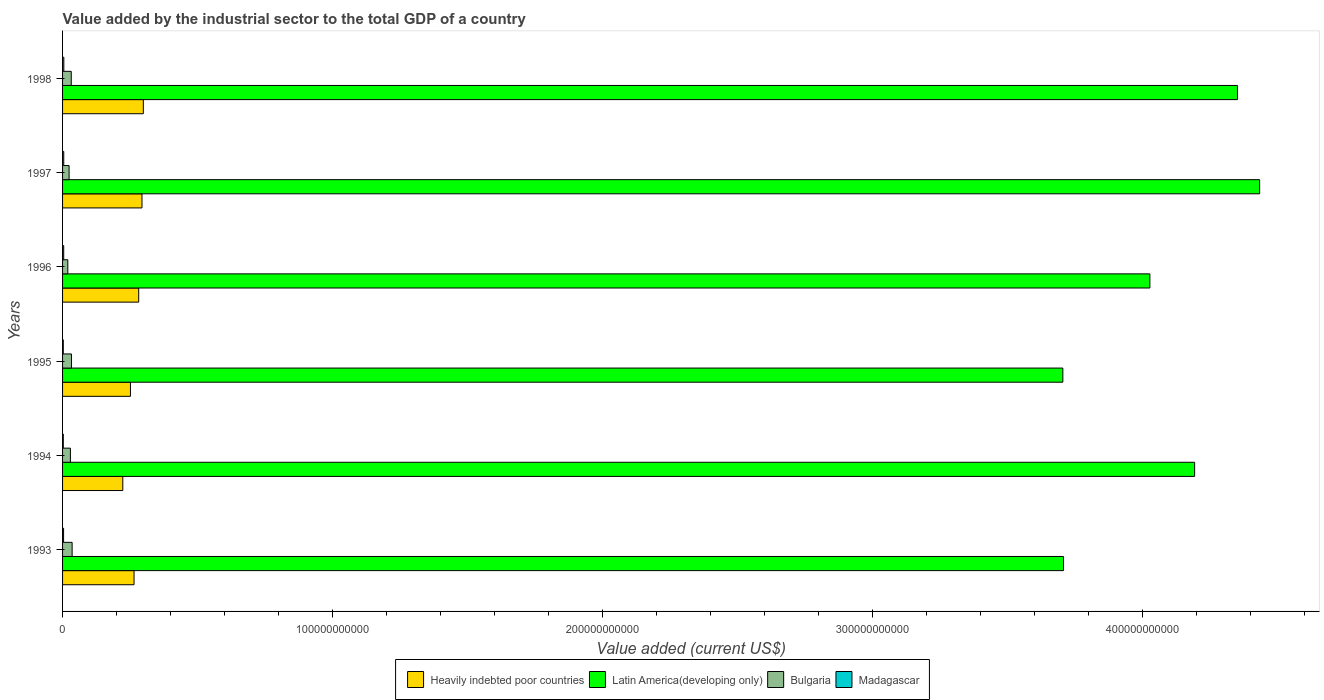How many groups of bars are there?
Your answer should be compact. 6. Are the number of bars per tick equal to the number of legend labels?
Provide a succinct answer. Yes. What is the value added by the industrial sector to the total GDP in Heavily indebted poor countries in 1994?
Ensure brevity in your answer.  2.23e+1. Across all years, what is the maximum value added by the industrial sector to the total GDP in Bulgaria?
Your answer should be compact. 3.54e+09. Across all years, what is the minimum value added by the industrial sector to the total GDP in Heavily indebted poor countries?
Keep it short and to the point. 2.23e+1. In which year was the value added by the industrial sector to the total GDP in Bulgaria maximum?
Give a very brief answer. 1993. What is the total value added by the industrial sector to the total GDP in Bulgaria in the graph?
Keep it short and to the point. 1.73e+1. What is the difference between the value added by the industrial sector to the total GDP in Madagascar in 1994 and that in 1997?
Provide a succinct answer. -1.69e+08. What is the difference between the value added by the industrial sector to the total GDP in Heavily indebted poor countries in 1994 and the value added by the industrial sector to the total GDP in Bulgaria in 1996?
Provide a succinct answer. 2.04e+1. What is the average value added by the industrial sector to the total GDP in Latin America(developing only) per year?
Your answer should be very brief. 4.07e+11. In the year 1993, what is the difference between the value added by the industrial sector to the total GDP in Latin America(developing only) and value added by the industrial sector to the total GDP in Bulgaria?
Provide a succinct answer. 3.67e+11. In how many years, is the value added by the industrial sector to the total GDP in Heavily indebted poor countries greater than 320000000000 US$?
Your response must be concise. 0. What is the ratio of the value added by the industrial sector to the total GDP in Madagascar in 1993 to that in 1996?
Provide a short and direct response. 0.88. Is the value added by the industrial sector to the total GDP in Bulgaria in 1994 less than that in 1998?
Make the answer very short. Yes. What is the difference between the highest and the second highest value added by the industrial sector to the total GDP in Latin America(developing only)?
Make the answer very short. 8.21e+09. What is the difference between the highest and the lowest value added by the industrial sector to the total GDP in Heavily indebted poor countries?
Your response must be concise. 7.60e+09. What does the 4th bar from the top in 1994 represents?
Offer a terse response. Heavily indebted poor countries. What does the 4th bar from the bottom in 1993 represents?
Your answer should be compact. Madagascar. Is it the case that in every year, the sum of the value added by the industrial sector to the total GDP in Heavily indebted poor countries and value added by the industrial sector to the total GDP in Latin America(developing only) is greater than the value added by the industrial sector to the total GDP in Madagascar?
Offer a terse response. Yes. How many bars are there?
Provide a short and direct response. 24. Are all the bars in the graph horizontal?
Your response must be concise. Yes. How many years are there in the graph?
Your response must be concise. 6. What is the difference between two consecutive major ticks on the X-axis?
Keep it short and to the point. 1.00e+11. Does the graph contain grids?
Offer a terse response. No. How are the legend labels stacked?
Your response must be concise. Horizontal. What is the title of the graph?
Provide a short and direct response. Value added by the industrial sector to the total GDP of a country. Does "Hong Kong" appear as one of the legend labels in the graph?
Provide a short and direct response. No. What is the label or title of the X-axis?
Your answer should be very brief. Value added (current US$). What is the Value added (current US$) of Heavily indebted poor countries in 1993?
Keep it short and to the point. 2.65e+1. What is the Value added (current US$) in Latin America(developing only) in 1993?
Offer a terse response. 3.71e+11. What is the Value added (current US$) of Bulgaria in 1993?
Your answer should be very brief. 3.54e+09. What is the Value added (current US$) in Madagascar in 1993?
Your response must be concise. 3.74e+08. What is the Value added (current US$) of Heavily indebted poor countries in 1994?
Provide a short and direct response. 2.23e+1. What is the Value added (current US$) in Latin America(developing only) in 1994?
Give a very brief answer. 4.19e+11. What is the Value added (current US$) of Bulgaria in 1994?
Provide a short and direct response. 2.90e+09. What is the Value added (current US$) of Madagascar in 1994?
Ensure brevity in your answer.  2.72e+08. What is the Value added (current US$) of Heavily indebted poor countries in 1995?
Your response must be concise. 2.51e+1. What is the Value added (current US$) in Latin America(developing only) in 1995?
Your response must be concise. 3.70e+11. What is the Value added (current US$) in Bulgaria in 1995?
Provide a succinct answer. 3.29e+09. What is the Value added (current US$) in Madagascar in 1995?
Provide a short and direct response. 2.71e+08. What is the Value added (current US$) in Heavily indebted poor countries in 1996?
Make the answer very short. 2.82e+1. What is the Value added (current US$) of Latin America(developing only) in 1996?
Your answer should be compact. 4.03e+11. What is the Value added (current US$) of Bulgaria in 1996?
Keep it short and to the point. 1.94e+09. What is the Value added (current US$) of Madagascar in 1996?
Provide a short and direct response. 4.23e+08. What is the Value added (current US$) of Heavily indebted poor countries in 1997?
Make the answer very short. 2.94e+1. What is the Value added (current US$) of Latin America(developing only) in 1997?
Your answer should be compact. 4.43e+11. What is the Value added (current US$) in Bulgaria in 1997?
Your answer should be compact. 2.42e+09. What is the Value added (current US$) in Madagascar in 1997?
Make the answer very short. 4.41e+08. What is the Value added (current US$) in Heavily indebted poor countries in 1998?
Make the answer very short. 2.99e+1. What is the Value added (current US$) of Latin America(developing only) in 1998?
Make the answer very short. 4.35e+11. What is the Value added (current US$) of Bulgaria in 1998?
Provide a short and direct response. 3.21e+09. What is the Value added (current US$) in Madagascar in 1998?
Your response must be concise. 4.69e+08. Across all years, what is the maximum Value added (current US$) of Heavily indebted poor countries?
Make the answer very short. 2.99e+1. Across all years, what is the maximum Value added (current US$) of Latin America(developing only)?
Your answer should be very brief. 4.43e+11. Across all years, what is the maximum Value added (current US$) in Bulgaria?
Offer a terse response. 3.54e+09. Across all years, what is the maximum Value added (current US$) in Madagascar?
Your response must be concise. 4.69e+08. Across all years, what is the minimum Value added (current US$) in Heavily indebted poor countries?
Make the answer very short. 2.23e+1. Across all years, what is the minimum Value added (current US$) of Latin America(developing only)?
Give a very brief answer. 3.70e+11. Across all years, what is the minimum Value added (current US$) in Bulgaria?
Keep it short and to the point. 1.94e+09. Across all years, what is the minimum Value added (current US$) in Madagascar?
Keep it short and to the point. 2.71e+08. What is the total Value added (current US$) in Heavily indebted poor countries in the graph?
Offer a terse response. 1.61e+11. What is the total Value added (current US$) of Latin America(developing only) in the graph?
Provide a succinct answer. 2.44e+12. What is the total Value added (current US$) in Bulgaria in the graph?
Your answer should be very brief. 1.73e+1. What is the total Value added (current US$) in Madagascar in the graph?
Your answer should be compact. 2.25e+09. What is the difference between the Value added (current US$) of Heavily indebted poor countries in 1993 and that in 1994?
Your response must be concise. 4.17e+09. What is the difference between the Value added (current US$) of Latin America(developing only) in 1993 and that in 1994?
Offer a terse response. -4.86e+1. What is the difference between the Value added (current US$) of Bulgaria in 1993 and that in 1994?
Your response must be concise. 6.36e+08. What is the difference between the Value added (current US$) of Madagascar in 1993 and that in 1994?
Make the answer very short. 1.02e+08. What is the difference between the Value added (current US$) of Heavily indebted poor countries in 1993 and that in 1995?
Offer a terse response. 1.33e+09. What is the difference between the Value added (current US$) in Latin America(developing only) in 1993 and that in 1995?
Your answer should be compact. 2.47e+08. What is the difference between the Value added (current US$) in Bulgaria in 1993 and that in 1995?
Provide a succinct answer. 2.48e+08. What is the difference between the Value added (current US$) in Madagascar in 1993 and that in 1995?
Provide a short and direct response. 1.03e+08. What is the difference between the Value added (current US$) of Heavily indebted poor countries in 1993 and that in 1996?
Provide a succinct answer. -1.72e+09. What is the difference between the Value added (current US$) in Latin America(developing only) in 1993 and that in 1996?
Your answer should be very brief. -3.20e+1. What is the difference between the Value added (current US$) of Bulgaria in 1993 and that in 1996?
Give a very brief answer. 1.60e+09. What is the difference between the Value added (current US$) of Madagascar in 1993 and that in 1996?
Ensure brevity in your answer.  -4.89e+07. What is the difference between the Value added (current US$) of Heavily indebted poor countries in 1993 and that in 1997?
Provide a succinct answer. -2.94e+09. What is the difference between the Value added (current US$) in Latin America(developing only) in 1993 and that in 1997?
Offer a terse response. -7.26e+1. What is the difference between the Value added (current US$) in Bulgaria in 1993 and that in 1997?
Give a very brief answer. 1.12e+09. What is the difference between the Value added (current US$) in Madagascar in 1993 and that in 1997?
Offer a very short reply. -6.70e+07. What is the difference between the Value added (current US$) of Heavily indebted poor countries in 1993 and that in 1998?
Your answer should be compact. -3.44e+09. What is the difference between the Value added (current US$) in Latin America(developing only) in 1993 and that in 1998?
Provide a succinct answer. -6.44e+1. What is the difference between the Value added (current US$) of Bulgaria in 1993 and that in 1998?
Your response must be concise. 3.26e+08. What is the difference between the Value added (current US$) of Madagascar in 1993 and that in 1998?
Give a very brief answer. -9.46e+07. What is the difference between the Value added (current US$) of Heavily indebted poor countries in 1994 and that in 1995?
Provide a short and direct response. -2.84e+09. What is the difference between the Value added (current US$) of Latin America(developing only) in 1994 and that in 1995?
Your answer should be very brief. 4.88e+1. What is the difference between the Value added (current US$) of Bulgaria in 1994 and that in 1995?
Ensure brevity in your answer.  -3.88e+08. What is the difference between the Value added (current US$) in Madagascar in 1994 and that in 1995?
Provide a succinct answer. 6.85e+05. What is the difference between the Value added (current US$) of Heavily indebted poor countries in 1994 and that in 1996?
Give a very brief answer. -5.89e+09. What is the difference between the Value added (current US$) of Latin America(developing only) in 1994 and that in 1996?
Your answer should be compact. 1.66e+1. What is the difference between the Value added (current US$) in Bulgaria in 1994 and that in 1996?
Make the answer very short. 9.64e+08. What is the difference between the Value added (current US$) of Madagascar in 1994 and that in 1996?
Give a very brief answer. -1.51e+08. What is the difference between the Value added (current US$) in Heavily indebted poor countries in 1994 and that in 1997?
Provide a short and direct response. -7.11e+09. What is the difference between the Value added (current US$) of Latin America(developing only) in 1994 and that in 1997?
Your answer should be compact. -2.41e+1. What is the difference between the Value added (current US$) in Bulgaria in 1994 and that in 1997?
Offer a terse response. 4.88e+08. What is the difference between the Value added (current US$) of Madagascar in 1994 and that in 1997?
Offer a very short reply. -1.69e+08. What is the difference between the Value added (current US$) in Heavily indebted poor countries in 1994 and that in 1998?
Give a very brief answer. -7.60e+09. What is the difference between the Value added (current US$) in Latin America(developing only) in 1994 and that in 1998?
Give a very brief answer. -1.59e+1. What is the difference between the Value added (current US$) in Bulgaria in 1994 and that in 1998?
Your response must be concise. -3.10e+08. What is the difference between the Value added (current US$) of Madagascar in 1994 and that in 1998?
Give a very brief answer. -1.97e+08. What is the difference between the Value added (current US$) of Heavily indebted poor countries in 1995 and that in 1996?
Provide a succinct answer. -3.05e+09. What is the difference between the Value added (current US$) of Latin America(developing only) in 1995 and that in 1996?
Offer a very short reply. -3.22e+1. What is the difference between the Value added (current US$) in Bulgaria in 1995 and that in 1996?
Keep it short and to the point. 1.35e+09. What is the difference between the Value added (current US$) of Madagascar in 1995 and that in 1996?
Keep it short and to the point. -1.52e+08. What is the difference between the Value added (current US$) in Heavily indebted poor countries in 1995 and that in 1997?
Give a very brief answer. -4.27e+09. What is the difference between the Value added (current US$) in Latin America(developing only) in 1995 and that in 1997?
Keep it short and to the point. -7.29e+1. What is the difference between the Value added (current US$) of Bulgaria in 1995 and that in 1997?
Keep it short and to the point. 8.76e+08. What is the difference between the Value added (current US$) of Madagascar in 1995 and that in 1997?
Your response must be concise. -1.70e+08. What is the difference between the Value added (current US$) in Heavily indebted poor countries in 1995 and that in 1998?
Offer a very short reply. -4.77e+09. What is the difference between the Value added (current US$) in Latin America(developing only) in 1995 and that in 1998?
Provide a succinct answer. -6.47e+1. What is the difference between the Value added (current US$) of Bulgaria in 1995 and that in 1998?
Offer a terse response. 7.84e+07. What is the difference between the Value added (current US$) in Madagascar in 1995 and that in 1998?
Make the answer very short. -1.98e+08. What is the difference between the Value added (current US$) in Heavily indebted poor countries in 1996 and that in 1997?
Ensure brevity in your answer.  -1.22e+09. What is the difference between the Value added (current US$) in Latin America(developing only) in 1996 and that in 1997?
Your answer should be very brief. -4.07e+1. What is the difference between the Value added (current US$) in Bulgaria in 1996 and that in 1997?
Provide a succinct answer. -4.76e+08. What is the difference between the Value added (current US$) in Madagascar in 1996 and that in 1997?
Provide a succinct answer. -1.81e+07. What is the difference between the Value added (current US$) of Heavily indebted poor countries in 1996 and that in 1998?
Offer a very short reply. -1.72e+09. What is the difference between the Value added (current US$) in Latin America(developing only) in 1996 and that in 1998?
Give a very brief answer. -3.24e+1. What is the difference between the Value added (current US$) of Bulgaria in 1996 and that in 1998?
Your answer should be very brief. -1.27e+09. What is the difference between the Value added (current US$) in Madagascar in 1996 and that in 1998?
Make the answer very short. -4.58e+07. What is the difference between the Value added (current US$) in Heavily indebted poor countries in 1997 and that in 1998?
Give a very brief answer. -4.99e+08. What is the difference between the Value added (current US$) in Latin America(developing only) in 1997 and that in 1998?
Provide a short and direct response. 8.21e+09. What is the difference between the Value added (current US$) in Bulgaria in 1997 and that in 1998?
Make the answer very short. -7.97e+08. What is the difference between the Value added (current US$) in Madagascar in 1997 and that in 1998?
Offer a terse response. -2.76e+07. What is the difference between the Value added (current US$) in Heavily indebted poor countries in 1993 and the Value added (current US$) in Latin America(developing only) in 1994?
Provide a succinct answer. -3.93e+11. What is the difference between the Value added (current US$) in Heavily indebted poor countries in 1993 and the Value added (current US$) in Bulgaria in 1994?
Provide a succinct answer. 2.36e+1. What is the difference between the Value added (current US$) of Heavily indebted poor countries in 1993 and the Value added (current US$) of Madagascar in 1994?
Keep it short and to the point. 2.62e+1. What is the difference between the Value added (current US$) in Latin America(developing only) in 1993 and the Value added (current US$) in Bulgaria in 1994?
Offer a very short reply. 3.68e+11. What is the difference between the Value added (current US$) of Latin America(developing only) in 1993 and the Value added (current US$) of Madagascar in 1994?
Ensure brevity in your answer.  3.70e+11. What is the difference between the Value added (current US$) in Bulgaria in 1993 and the Value added (current US$) in Madagascar in 1994?
Give a very brief answer. 3.27e+09. What is the difference between the Value added (current US$) of Heavily indebted poor countries in 1993 and the Value added (current US$) of Latin America(developing only) in 1995?
Keep it short and to the point. -3.44e+11. What is the difference between the Value added (current US$) of Heavily indebted poor countries in 1993 and the Value added (current US$) of Bulgaria in 1995?
Your response must be concise. 2.32e+1. What is the difference between the Value added (current US$) of Heavily indebted poor countries in 1993 and the Value added (current US$) of Madagascar in 1995?
Provide a short and direct response. 2.62e+1. What is the difference between the Value added (current US$) in Latin America(developing only) in 1993 and the Value added (current US$) in Bulgaria in 1995?
Your response must be concise. 3.67e+11. What is the difference between the Value added (current US$) of Latin America(developing only) in 1993 and the Value added (current US$) of Madagascar in 1995?
Offer a terse response. 3.70e+11. What is the difference between the Value added (current US$) in Bulgaria in 1993 and the Value added (current US$) in Madagascar in 1995?
Your answer should be very brief. 3.27e+09. What is the difference between the Value added (current US$) in Heavily indebted poor countries in 1993 and the Value added (current US$) in Latin America(developing only) in 1996?
Offer a terse response. -3.76e+11. What is the difference between the Value added (current US$) in Heavily indebted poor countries in 1993 and the Value added (current US$) in Bulgaria in 1996?
Your answer should be compact. 2.45e+1. What is the difference between the Value added (current US$) of Heavily indebted poor countries in 1993 and the Value added (current US$) of Madagascar in 1996?
Your answer should be very brief. 2.60e+1. What is the difference between the Value added (current US$) in Latin America(developing only) in 1993 and the Value added (current US$) in Bulgaria in 1996?
Your response must be concise. 3.69e+11. What is the difference between the Value added (current US$) in Latin America(developing only) in 1993 and the Value added (current US$) in Madagascar in 1996?
Keep it short and to the point. 3.70e+11. What is the difference between the Value added (current US$) of Bulgaria in 1993 and the Value added (current US$) of Madagascar in 1996?
Your answer should be very brief. 3.12e+09. What is the difference between the Value added (current US$) in Heavily indebted poor countries in 1993 and the Value added (current US$) in Latin America(developing only) in 1997?
Your response must be concise. -4.17e+11. What is the difference between the Value added (current US$) in Heavily indebted poor countries in 1993 and the Value added (current US$) in Bulgaria in 1997?
Make the answer very short. 2.41e+1. What is the difference between the Value added (current US$) in Heavily indebted poor countries in 1993 and the Value added (current US$) in Madagascar in 1997?
Make the answer very short. 2.60e+1. What is the difference between the Value added (current US$) of Latin America(developing only) in 1993 and the Value added (current US$) of Bulgaria in 1997?
Give a very brief answer. 3.68e+11. What is the difference between the Value added (current US$) of Latin America(developing only) in 1993 and the Value added (current US$) of Madagascar in 1997?
Your answer should be very brief. 3.70e+11. What is the difference between the Value added (current US$) in Bulgaria in 1993 and the Value added (current US$) in Madagascar in 1997?
Keep it short and to the point. 3.10e+09. What is the difference between the Value added (current US$) in Heavily indebted poor countries in 1993 and the Value added (current US$) in Latin America(developing only) in 1998?
Your response must be concise. -4.09e+11. What is the difference between the Value added (current US$) in Heavily indebted poor countries in 1993 and the Value added (current US$) in Bulgaria in 1998?
Your response must be concise. 2.33e+1. What is the difference between the Value added (current US$) in Heavily indebted poor countries in 1993 and the Value added (current US$) in Madagascar in 1998?
Your answer should be compact. 2.60e+1. What is the difference between the Value added (current US$) of Latin America(developing only) in 1993 and the Value added (current US$) of Bulgaria in 1998?
Make the answer very short. 3.67e+11. What is the difference between the Value added (current US$) of Latin America(developing only) in 1993 and the Value added (current US$) of Madagascar in 1998?
Offer a very short reply. 3.70e+11. What is the difference between the Value added (current US$) of Bulgaria in 1993 and the Value added (current US$) of Madagascar in 1998?
Make the answer very short. 3.07e+09. What is the difference between the Value added (current US$) of Heavily indebted poor countries in 1994 and the Value added (current US$) of Latin America(developing only) in 1995?
Your answer should be very brief. -3.48e+11. What is the difference between the Value added (current US$) of Heavily indebted poor countries in 1994 and the Value added (current US$) of Bulgaria in 1995?
Offer a terse response. 1.90e+1. What is the difference between the Value added (current US$) of Heavily indebted poor countries in 1994 and the Value added (current US$) of Madagascar in 1995?
Your answer should be compact. 2.20e+1. What is the difference between the Value added (current US$) in Latin America(developing only) in 1994 and the Value added (current US$) in Bulgaria in 1995?
Provide a short and direct response. 4.16e+11. What is the difference between the Value added (current US$) in Latin America(developing only) in 1994 and the Value added (current US$) in Madagascar in 1995?
Give a very brief answer. 4.19e+11. What is the difference between the Value added (current US$) of Bulgaria in 1994 and the Value added (current US$) of Madagascar in 1995?
Provide a short and direct response. 2.63e+09. What is the difference between the Value added (current US$) of Heavily indebted poor countries in 1994 and the Value added (current US$) of Latin America(developing only) in 1996?
Provide a succinct answer. -3.80e+11. What is the difference between the Value added (current US$) in Heavily indebted poor countries in 1994 and the Value added (current US$) in Bulgaria in 1996?
Make the answer very short. 2.04e+1. What is the difference between the Value added (current US$) in Heavily indebted poor countries in 1994 and the Value added (current US$) in Madagascar in 1996?
Provide a succinct answer. 2.19e+1. What is the difference between the Value added (current US$) in Latin America(developing only) in 1994 and the Value added (current US$) in Bulgaria in 1996?
Provide a succinct answer. 4.17e+11. What is the difference between the Value added (current US$) of Latin America(developing only) in 1994 and the Value added (current US$) of Madagascar in 1996?
Your answer should be very brief. 4.19e+11. What is the difference between the Value added (current US$) in Bulgaria in 1994 and the Value added (current US$) in Madagascar in 1996?
Provide a succinct answer. 2.48e+09. What is the difference between the Value added (current US$) in Heavily indebted poor countries in 1994 and the Value added (current US$) in Latin America(developing only) in 1997?
Your answer should be compact. -4.21e+11. What is the difference between the Value added (current US$) in Heavily indebted poor countries in 1994 and the Value added (current US$) in Bulgaria in 1997?
Give a very brief answer. 1.99e+1. What is the difference between the Value added (current US$) of Heavily indebted poor countries in 1994 and the Value added (current US$) of Madagascar in 1997?
Provide a short and direct response. 2.19e+1. What is the difference between the Value added (current US$) of Latin America(developing only) in 1994 and the Value added (current US$) of Bulgaria in 1997?
Make the answer very short. 4.17e+11. What is the difference between the Value added (current US$) of Latin America(developing only) in 1994 and the Value added (current US$) of Madagascar in 1997?
Give a very brief answer. 4.19e+11. What is the difference between the Value added (current US$) of Bulgaria in 1994 and the Value added (current US$) of Madagascar in 1997?
Offer a terse response. 2.46e+09. What is the difference between the Value added (current US$) of Heavily indebted poor countries in 1994 and the Value added (current US$) of Latin America(developing only) in 1998?
Offer a very short reply. -4.13e+11. What is the difference between the Value added (current US$) of Heavily indebted poor countries in 1994 and the Value added (current US$) of Bulgaria in 1998?
Offer a terse response. 1.91e+1. What is the difference between the Value added (current US$) of Heavily indebted poor countries in 1994 and the Value added (current US$) of Madagascar in 1998?
Offer a terse response. 2.18e+1. What is the difference between the Value added (current US$) in Latin America(developing only) in 1994 and the Value added (current US$) in Bulgaria in 1998?
Your response must be concise. 4.16e+11. What is the difference between the Value added (current US$) in Latin America(developing only) in 1994 and the Value added (current US$) in Madagascar in 1998?
Give a very brief answer. 4.19e+11. What is the difference between the Value added (current US$) of Bulgaria in 1994 and the Value added (current US$) of Madagascar in 1998?
Make the answer very short. 2.44e+09. What is the difference between the Value added (current US$) in Heavily indebted poor countries in 1995 and the Value added (current US$) in Latin America(developing only) in 1996?
Provide a succinct answer. -3.78e+11. What is the difference between the Value added (current US$) of Heavily indebted poor countries in 1995 and the Value added (current US$) of Bulgaria in 1996?
Keep it short and to the point. 2.32e+1. What is the difference between the Value added (current US$) of Heavily indebted poor countries in 1995 and the Value added (current US$) of Madagascar in 1996?
Your response must be concise. 2.47e+1. What is the difference between the Value added (current US$) in Latin America(developing only) in 1995 and the Value added (current US$) in Bulgaria in 1996?
Ensure brevity in your answer.  3.68e+11. What is the difference between the Value added (current US$) in Latin America(developing only) in 1995 and the Value added (current US$) in Madagascar in 1996?
Make the answer very short. 3.70e+11. What is the difference between the Value added (current US$) of Bulgaria in 1995 and the Value added (current US$) of Madagascar in 1996?
Provide a succinct answer. 2.87e+09. What is the difference between the Value added (current US$) of Heavily indebted poor countries in 1995 and the Value added (current US$) of Latin America(developing only) in 1997?
Offer a very short reply. -4.18e+11. What is the difference between the Value added (current US$) in Heavily indebted poor countries in 1995 and the Value added (current US$) in Bulgaria in 1997?
Make the answer very short. 2.27e+1. What is the difference between the Value added (current US$) of Heavily indebted poor countries in 1995 and the Value added (current US$) of Madagascar in 1997?
Provide a short and direct response. 2.47e+1. What is the difference between the Value added (current US$) in Latin America(developing only) in 1995 and the Value added (current US$) in Bulgaria in 1997?
Your answer should be very brief. 3.68e+11. What is the difference between the Value added (current US$) of Latin America(developing only) in 1995 and the Value added (current US$) of Madagascar in 1997?
Offer a terse response. 3.70e+11. What is the difference between the Value added (current US$) of Bulgaria in 1995 and the Value added (current US$) of Madagascar in 1997?
Your answer should be compact. 2.85e+09. What is the difference between the Value added (current US$) of Heavily indebted poor countries in 1995 and the Value added (current US$) of Latin America(developing only) in 1998?
Your response must be concise. -4.10e+11. What is the difference between the Value added (current US$) of Heavily indebted poor countries in 1995 and the Value added (current US$) of Bulgaria in 1998?
Keep it short and to the point. 2.19e+1. What is the difference between the Value added (current US$) in Heavily indebted poor countries in 1995 and the Value added (current US$) in Madagascar in 1998?
Keep it short and to the point. 2.47e+1. What is the difference between the Value added (current US$) in Latin America(developing only) in 1995 and the Value added (current US$) in Bulgaria in 1998?
Keep it short and to the point. 3.67e+11. What is the difference between the Value added (current US$) in Latin America(developing only) in 1995 and the Value added (current US$) in Madagascar in 1998?
Provide a short and direct response. 3.70e+11. What is the difference between the Value added (current US$) of Bulgaria in 1995 and the Value added (current US$) of Madagascar in 1998?
Provide a short and direct response. 2.82e+09. What is the difference between the Value added (current US$) in Heavily indebted poor countries in 1996 and the Value added (current US$) in Latin America(developing only) in 1997?
Ensure brevity in your answer.  -4.15e+11. What is the difference between the Value added (current US$) in Heavily indebted poor countries in 1996 and the Value added (current US$) in Bulgaria in 1997?
Provide a succinct answer. 2.58e+1. What is the difference between the Value added (current US$) of Heavily indebted poor countries in 1996 and the Value added (current US$) of Madagascar in 1997?
Make the answer very short. 2.78e+1. What is the difference between the Value added (current US$) in Latin America(developing only) in 1996 and the Value added (current US$) in Bulgaria in 1997?
Provide a succinct answer. 4.00e+11. What is the difference between the Value added (current US$) in Latin America(developing only) in 1996 and the Value added (current US$) in Madagascar in 1997?
Your answer should be compact. 4.02e+11. What is the difference between the Value added (current US$) of Bulgaria in 1996 and the Value added (current US$) of Madagascar in 1997?
Keep it short and to the point. 1.50e+09. What is the difference between the Value added (current US$) in Heavily indebted poor countries in 1996 and the Value added (current US$) in Latin America(developing only) in 1998?
Your response must be concise. -4.07e+11. What is the difference between the Value added (current US$) in Heavily indebted poor countries in 1996 and the Value added (current US$) in Bulgaria in 1998?
Provide a succinct answer. 2.50e+1. What is the difference between the Value added (current US$) in Heavily indebted poor countries in 1996 and the Value added (current US$) in Madagascar in 1998?
Your answer should be very brief. 2.77e+1. What is the difference between the Value added (current US$) in Latin America(developing only) in 1996 and the Value added (current US$) in Bulgaria in 1998?
Keep it short and to the point. 3.99e+11. What is the difference between the Value added (current US$) of Latin America(developing only) in 1996 and the Value added (current US$) of Madagascar in 1998?
Offer a terse response. 4.02e+11. What is the difference between the Value added (current US$) of Bulgaria in 1996 and the Value added (current US$) of Madagascar in 1998?
Your response must be concise. 1.47e+09. What is the difference between the Value added (current US$) in Heavily indebted poor countries in 1997 and the Value added (current US$) in Latin America(developing only) in 1998?
Provide a short and direct response. -4.06e+11. What is the difference between the Value added (current US$) of Heavily indebted poor countries in 1997 and the Value added (current US$) of Bulgaria in 1998?
Offer a very short reply. 2.62e+1. What is the difference between the Value added (current US$) in Heavily indebted poor countries in 1997 and the Value added (current US$) in Madagascar in 1998?
Give a very brief answer. 2.89e+1. What is the difference between the Value added (current US$) in Latin America(developing only) in 1997 and the Value added (current US$) in Bulgaria in 1998?
Offer a very short reply. 4.40e+11. What is the difference between the Value added (current US$) of Latin America(developing only) in 1997 and the Value added (current US$) of Madagascar in 1998?
Provide a succinct answer. 4.43e+11. What is the difference between the Value added (current US$) in Bulgaria in 1997 and the Value added (current US$) in Madagascar in 1998?
Your answer should be very brief. 1.95e+09. What is the average Value added (current US$) of Heavily indebted poor countries per year?
Give a very brief answer. 2.69e+1. What is the average Value added (current US$) of Latin America(developing only) per year?
Your answer should be very brief. 4.07e+11. What is the average Value added (current US$) of Bulgaria per year?
Your answer should be compact. 2.88e+09. What is the average Value added (current US$) of Madagascar per year?
Give a very brief answer. 3.75e+08. In the year 1993, what is the difference between the Value added (current US$) in Heavily indebted poor countries and Value added (current US$) in Latin America(developing only)?
Ensure brevity in your answer.  -3.44e+11. In the year 1993, what is the difference between the Value added (current US$) of Heavily indebted poor countries and Value added (current US$) of Bulgaria?
Give a very brief answer. 2.29e+1. In the year 1993, what is the difference between the Value added (current US$) of Heavily indebted poor countries and Value added (current US$) of Madagascar?
Your answer should be very brief. 2.61e+1. In the year 1993, what is the difference between the Value added (current US$) in Latin America(developing only) and Value added (current US$) in Bulgaria?
Offer a terse response. 3.67e+11. In the year 1993, what is the difference between the Value added (current US$) of Latin America(developing only) and Value added (current US$) of Madagascar?
Offer a terse response. 3.70e+11. In the year 1993, what is the difference between the Value added (current US$) in Bulgaria and Value added (current US$) in Madagascar?
Offer a very short reply. 3.17e+09. In the year 1994, what is the difference between the Value added (current US$) of Heavily indebted poor countries and Value added (current US$) of Latin America(developing only)?
Give a very brief answer. -3.97e+11. In the year 1994, what is the difference between the Value added (current US$) in Heavily indebted poor countries and Value added (current US$) in Bulgaria?
Make the answer very short. 1.94e+1. In the year 1994, what is the difference between the Value added (current US$) of Heavily indebted poor countries and Value added (current US$) of Madagascar?
Ensure brevity in your answer.  2.20e+1. In the year 1994, what is the difference between the Value added (current US$) in Latin America(developing only) and Value added (current US$) in Bulgaria?
Offer a terse response. 4.16e+11. In the year 1994, what is the difference between the Value added (current US$) of Latin America(developing only) and Value added (current US$) of Madagascar?
Keep it short and to the point. 4.19e+11. In the year 1994, what is the difference between the Value added (current US$) in Bulgaria and Value added (current US$) in Madagascar?
Ensure brevity in your answer.  2.63e+09. In the year 1995, what is the difference between the Value added (current US$) in Heavily indebted poor countries and Value added (current US$) in Latin America(developing only)?
Provide a short and direct response. -3.45e+11. In the year 1995, what is the difference between the Value added (current US$) in Heavily indebted poor countries and Value added (current US$) in Bulgaria?
Your response must be concise. 2.19e+1. In the year 1995, what is the difference between the Value added (current US$) in Heavily indebted poor countries and Value added (current US$) in Madagascar?
Offer a terse response. 2.49e+1. In the year 1995, what is the difference between the Value added (current US$) of Latin America(developing only) and Value added (current US$) of Bulgaria?
Offer a terse response. 3.67e+11. In the year 1995, what is the difference between the Value added (current US$) in Latin America(developing only) and Value added (current US$) in Madagascar?
Provide a short and direct response. 3.70e+11. In the year 1995, what is the difference between the Value added (current US$) in Bulgaria and Value added (current US$) in Madagascar?
Offer a terse response. 3.02e+09. In the year 1996, what is the difference between the Value added (current US$) of Heavily indebted poor countries and Value added (current US$) of Latin America(developing only)?
Provide a succinct answer. -3.74e+11. In the year 1996, what is the difference between the Value added (current US$) of Heavily indebted poor countries and Value added (current US$) of Bulgaria?
Offer a terse response. 2.63e+1. In the year 1996, what is the difference between the Value added (current US$) in Heavily indebted poor countries and Value added (current US$) in Madagascar?
Make the answer very short. 2.78e+1. In the year 1996, what is the difference between the Value added (current US$) in Latin America(developing only) and Value added (current US$) in Bulgaria?
Keep it short and to the point. 4.01e+11. In the year 1996, what is the difference between the Value added (current US$) in Latin America(developing only) and Value added (current US$) in Madagascar?
Give a very brief answer. 4.02e+11. In the year 1996, what is the difference between the Value added (current US$) in Bulgaria and Value added (current US$) in Madagascar?
Provide a short and direct response. 1.52e+09. In the year 1997, what is the difference between the Value added (current US$) of Heavily indebted poor countries and Value added (current US$) of Latin America(developing only)?
Provide a succinct answer. -4.14e+11. In the year 1997, what is the difference between the Value added (current US$) in Heavily indebted poor countries and Value added (current US$) in Bulgaria?
Offer a very short reply. 2.70e+1. In the year 1997, what is the difference between the Value added (current US$) in Heavily indebted poor countries and Value added (current US$) in Madagascar?
Offer a terse response. 2.90e+1. In the year 1997, what is the difference between the Value added (current US$) in Latin America(developing only) and Value added (current US$) in Bulgaria?
Give a very brief answer. 4.41e+11. In the year 1997, what is the difference between the Value added (current US$) in Latin America(developing only) and Value added (current US$) in Madagascar?
Provide a short and direct response. 4.43e+11. In the year 1997, what is the difference between the Value added (current US$) of Bulgaria and Value added (current US$) of Madagascar?
Offer a very short reply. 1.98e+09. In the year 1998, what is the difference between the Value added (current US$) in Heavily indebted poor countries and Value added (current US$) in Latin America(developing only)?
Offer a very short reply. -4.05e+11. In the year 1998, what is the difference between the Value added (current US$) of Heavily indebted poor countries and Value added (current US$) of Bulgaria?
Provide a succinct answer. 2.67e+1. In the year 1998, what is the difference between the Value added (current US$) of Heavily indebted poor countries and Value added (current US$) of Madagascar?
Provide a succinct answer. 2.94e+1. In the year 1998, what is the difference between the Value added (current US$) in Latin America(developing only) and Value added (current US$) in Bulgaria?
Make the answer very short. 4.32e+11. In the year 1998, what is the difference between the Value added (current US$) of Latin America(developing only) and Value added (current US$) of Madagascar?
Offer a very short reply. 4.35e+11. In the year 1998, what is the difference between the Value added (current US$) in Bulgaria and Value added (current US$) in Madagascar?
Make the answer very short. 2.75e+09. What is the ratio of the Value added (current US$) in Heavily indebted poor countries in 1993 to that in 1994?
Make the answer very short. 1.19. What is the ratio of the Value added (current US$) of Latin America(developing only) in 1993 to that in 1994?
Ensure brevity in your answer.  0.88. What is the ratio of the Value added (current US$) of Bulgaria in 1993 to that in 1994?
Give a very brief answer. 1.22. What is the ratio of the Value added (current US$) of Madagascar in 1993 to that in 1994?
Provide a short and direct response. 1.38. What is the ratio of the Value added (current US$) in Heavily indebted poor countries in 1993 to that in 1995?
Provide a succinct answer. 1.05. What is the ratio of the Value added (current US$) in Latin America(developing only) in 1993 to that in 1995?
Your answer should be compact. 1. What is the ratio of the Value added (current US$) in Bulgaria in 1993 to that in 1995?
Give a very brief answer. 1.08. What is the ratio of the Value added (current US$) in Madagascar in 1993 to that in 1995?
Offer a very short reply. 1.38. What is the ratio of the Value added (current US$) of Heavily indebted poor countries in 1993 to that in 1996?
Your response must be concise. 0.94. What is the ratio of the Value added (current US$) of Latin America(developing only) in 1993 to that in 1996?
Your answer should be very brief. 0.92. What is the ratio of the Value added (current US$) of Bulgaria in 1993 to that in 1996?
Offer a very short reply. 1.82. What is the ratio of the Value added (current US$) of Madagascar in 1993 to that in 1996?
Ensure brevity in your answer.  0.88. What is the ratio of the Value added (current US$) in Heavily indebted poor countries in 1993 to that in 1997?
Keep it short and to the point. 0.9. What is the ratio of the Value added (current US$) in Latin America(developing only) in 1993 to that in 1997?
Your answer should be compact. 0.84. What is the ratio of the Value added (current US$) in Bulgaria in 1993 to that in 1997?
Provide a succinct answer. 1.47. What is the ratio of the Value added (current US$) in Madagascar in 1993 to that in 1997?
Ensure brevity in your answer.  0.85. What is the ratio of the Value added (current US$) in Heavily indebted poor countries in 1993 to that in 1998?
Give a very brief answer. 0.89. What is the ratio of the Value added (current US$) in Latin America(developing only) in 1993 to that in 1998?
Offer a terse response. 0.85. What is the ratio of the Value added (current US$) in Bulgaria in 1993 to that in 1998?
Offer a very short reply. 1.1. What is the ratio of the Value added (current US$) in Madagascar in 1993 to that in 1998?
Offer a terse response. 0.8. What is the ratio of the Value added (current US$) in Heavily indebted poor countries in 1994 to that in 1995?
Give a very brief answer. 0.89. What is the ratio of the Value added (current US$) of Latin America(developing only) in 1994 to that in 1995?
Give a very brief answer. 1.13. What is the ratio of the Value added (current US$) of Bulgaria in 1994 to that in 1995?
Provide a short and direct response. 0.88. What is the ratio of the Value added (current US$) in Heavily indebted poor countries in 1994 to that in 1996?
Make the answer very short. 0.79. What is the ratio of the Value added (current US$) in Latin America(developing only) in 1994 to that in 1996?
Provide a short and direct response. 1.04. What is the ratio of the Value added (current US$) of Bulgaria in 1994 to that in 1996?
Provide a succinct answer. 1.5. What is the ratio of the Value added (current US$) of Madagascar in 1994 to that in 1996?
Offer a very short reply. 0.64. What is the ratio of the Value added (current US$) of Heavily indebted poor countries in 1994 to that in 1997?
Offer a terse response. 0.76. What is the ratio of the Value added (current US$) of Latin America(developing only) in 1994 to that in 1997?
Keep it short and to the point. 0.95. What is the ratio of the Value added (current US$) of Bulgaria in 1994 to that in 1997?
Keep it short and to the point. 1.2. What is the ratio of the Value added (current US$) of Madagascar in 1994 to that in 1997?
Give a very brief answer. 0.62. What is the ratio of the Value added (current US$) in Heavily indebted poor countries in 1994 to that in 1998?
Your answer should be very brief. 0.75. What is the ratio of the Value added (current US$) of Latin America(developing only) in 1994 to that in 1998?
Keep it short and to the point. 0.96. What is the ratio of the Value added (current US$) in Bulgaria in 1994 to that in 1998?
Your answer should be very brief. 0.9. What is the ratio of the Value added (current US$) in Madagascar in 1994 to that in 1998?
Make the answer very short. 0.58. What is the ratio of the Value added (current US$) in Heavily indebted poor countries in 1995 to that in 1996?
Give a very brief answer. 0.89. What is the ratio of the Value added (current US$) of Bulgaria in 1995 to that in 1996?
Provide a succinct answer. 1.7. What is the ratio of the Value added (current US$) of Madagascar in 1995 to that in 1996?
Your answer should be very brief. 0.64. What is the ratio of the Value added (current US$) of Heavily indebted poor countries in 1995 to that in 1997?
Give a very brief answer. 0.85. What is the ratio of the Value added (current US$) of Latin America(developing only) in 1995 to that in 1997?
Make the answer very short. 0.84. What is the ratio of the Value added (current US$) in Bulgaria in 1995 to that in 1997?
Make the answer very short. 1.36. What is the ratio of the Value added (current US$) of Madagascar in 1995 to that in 1997?
Offer a very short reply. 0.61. What is the ratio of the Value added (current US$) of Heavily indebted poor countries in 1995 to that in 1998?
Provide a succinct answer. 0.84. What is the ratio of the Value added (current US$) of Latin America(developing only) in 1995 to that in 1998?
Your response must be concise. 0.85. What is the ratio of the Value added (current US$) of Bulgaria in 1995 to that in 1998?
Provide a succinct answer. 1.02. What is the ratio of the Value added (current US$) in Madagascar in 1995 to that in 1998?
Offer a terse response. 0.58. What is the ratio of the Value added (current US$) in Heavily indebted poor countries in 1996 to that in 1997?
Provide a short and direct response. 0.96. What is the ratio of the Value added (current US$) of Latin America(developing only) in 1996 to that in 1997?
Offer a terse response. 0.91. What is the ratio of the Value added (current US$) of Bulgaria in 1996 to that in 1997?
Ensure brevity in your answer.  0.8. What is the ratio of the Value added (current US$) in Madagascar in 1996 to that in 1997?
Provide a short and direct response. 0.96. What is the ratio of the Value added (current US$) of Heavily indebted poor countries in 1996 to that in 1998?
Provide a succinct answer. 0.94. What is the ratio of the Value added (current US$) of Latin America(developing only) in 1996 to that in 1998?
Offer a very short reply. 0.93. What is the ratio of the Value added (current US$) of Bulgaria in 1996 to that in 1998?
Offer a very short reply. 0.6. What is the ratio of the Value added (current US$) of Madagascar in 1996 to that in 1998?
Provide a succinct answer. 0.9. What is the ratio of the Value added (current US$) in Heavily indebted poor countries in 1997 to that in 1998?
Your answer should be very brief. 0.98. What is the ratio of the Value added (current US$) in Latin America(developing only) in 1997 to that in 1998?
Your response must be concise. 1.02. What is the ratio of the Value added (current US$) of Bulgaria in 1997 to that in 1998?
Provide a short and direct response. 0.75. What is the ratio of the Value added (current US$) of Madagascar in 1997 to that in 1998?
Make the answer very short. 0.94. What is the difference between the highest and the second highest Value added (current US$) of Heavily indebted poor countries?
Your response must be concise. 4.99e+08. What is the difference between the highest and the second highest Value added (current US$) of Latin America(developing only)?
Make the answer very short. 8.21e+09. What is the difference between the highest and the second highest Value added (current US$) in Bulgaria?
Provide a short and direct response. 2.48e+08. What is the difference between the highest and the second highest Value added (current US$) in Madagascar?
Keep it short and to the point. 2.76e+07. What is the difference between the highest and the lowest Value added (current US$) in Heavily indebted poor countries?
Your response must be concise. 7.60e+09. What is the difference between the highest and the lowest Value added (current US$) of Latin America(developing only)?
Your response must be concise. 7.29e+1. What is the difference between the highest and the lowest Value added (current US$) of Bulgaria?
Your answer should be compact. 1.60e+09. What is the difference between the highest and the lowest Value added (current US$) of Madagascar?
Ensure brevity in your answer.  1.98e+08. 